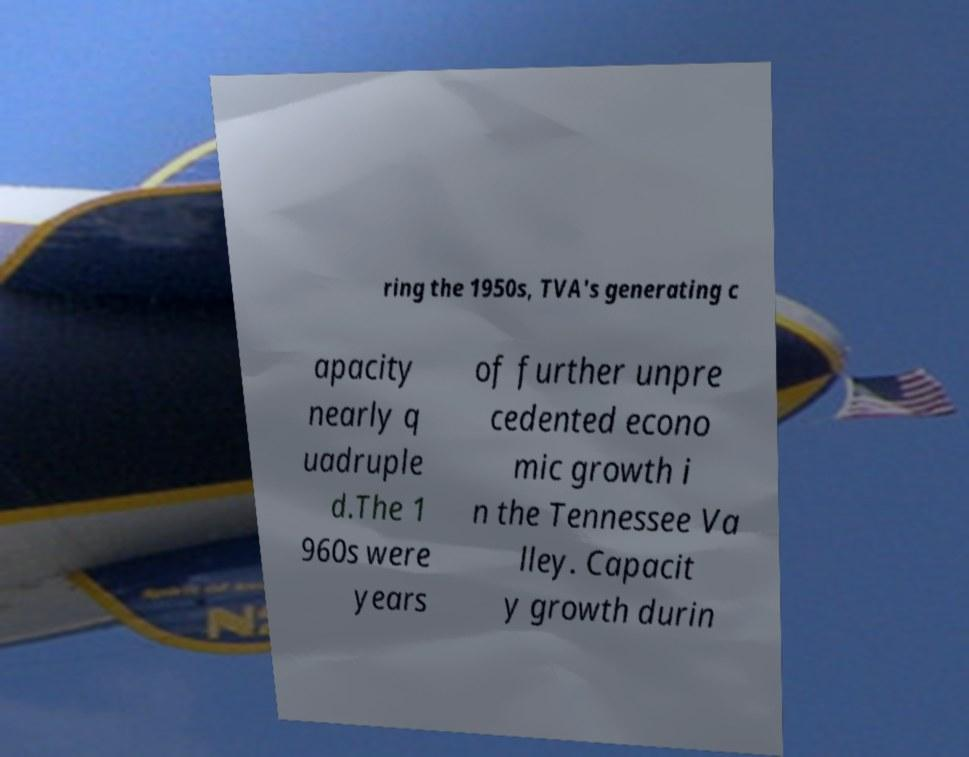What messages or text are displayed in this image? I need them in a readable, typed format. ring the 1950s, TVA's generating c apacity nearly q uadruple d.The 1 960s were years of further unpre cedented econo mic growth i n the Tennessee Va lley. Capacit y growth durin 